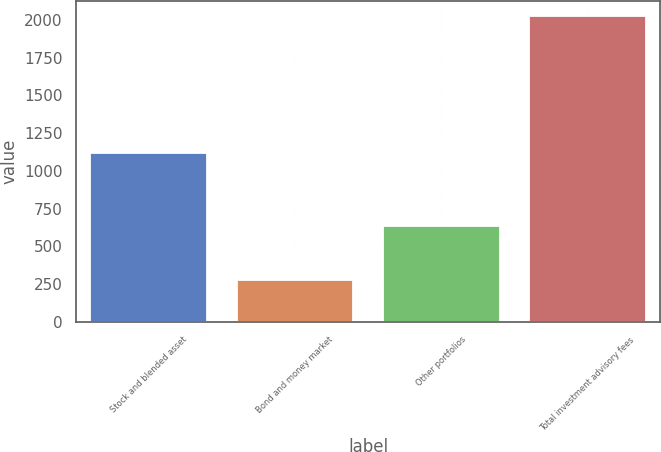Convert chart. <chart><loc_0><loc_0><loc_500><loc_500><bar_chart><fcel>Stock and blended asset<fcel>Bond and money market<fcel>Other portfolios<fcel>Total investment advisory fees<nl><fcel>1116.3<fcel>278<fcel>632.5<fcel>2026.8<nl></chart> 